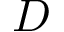<formula> <loc_0><loc_0><loc_500><loc_500>D</formula> 